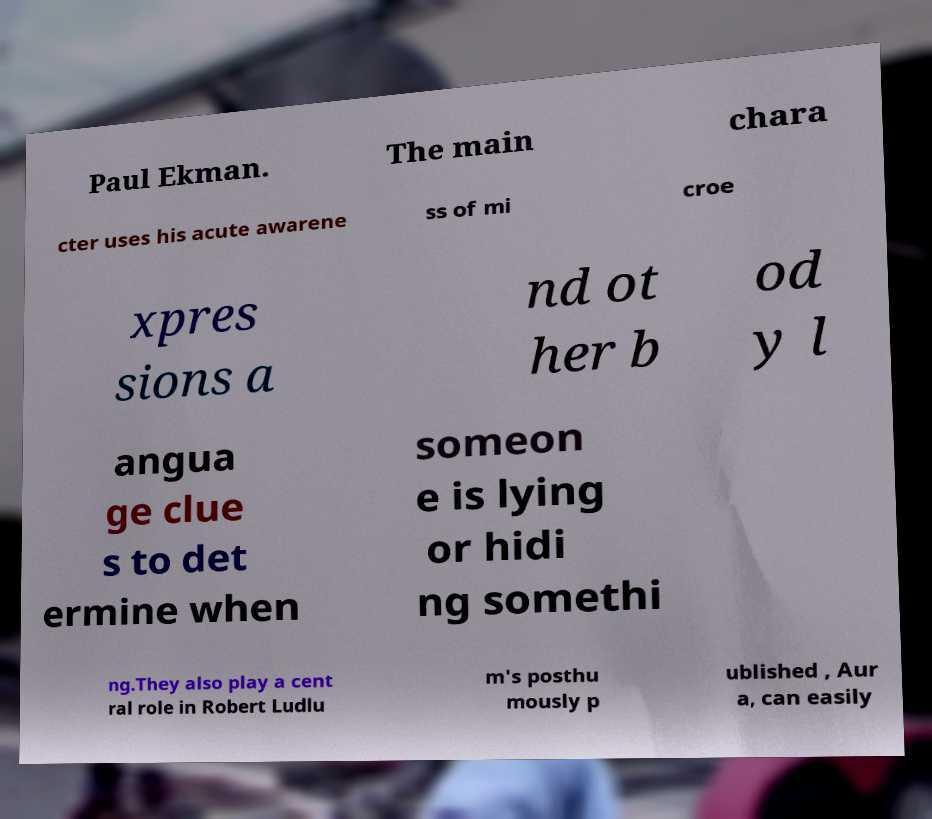There's text embedded in this image that I need extracted. Can you transcribe it verbatim? Paul Ekman. The main chara cter uses his acute awarene ss of mi croe xpres sions a nd ot her b od y l angua ge clue s to det ermine when someon e is lying or hidi ng somethi ng.They also play a cent ral role in Robert Ludlu m's posthu mously p ublished , Aur a, can easily 